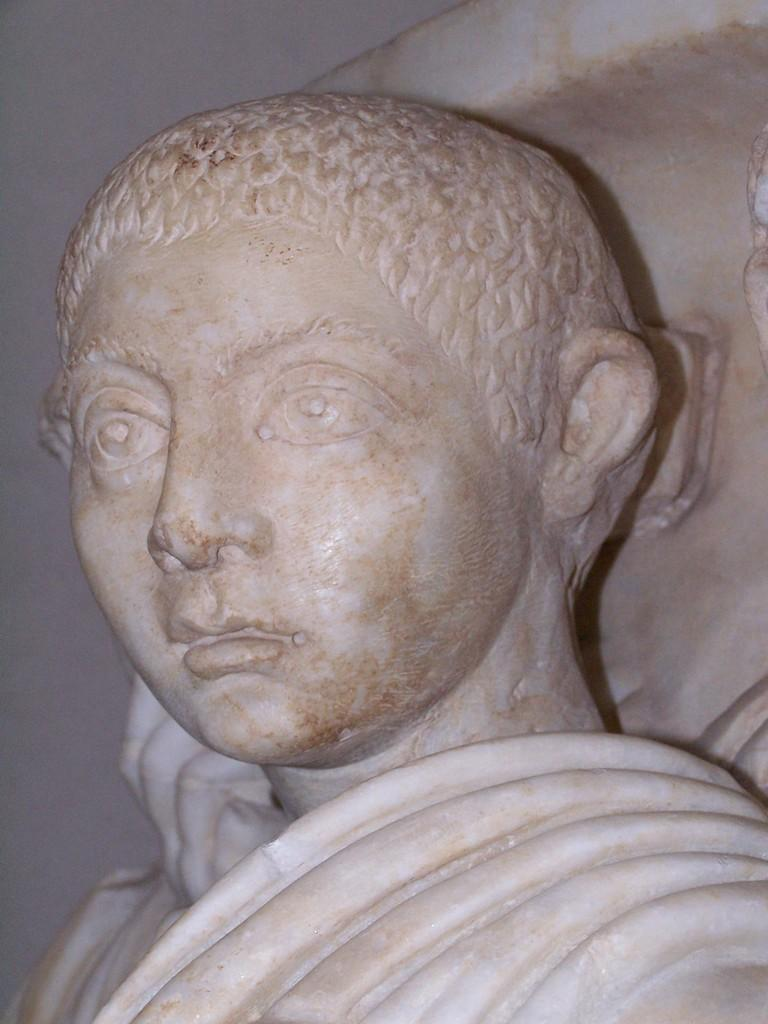What is the main subject in the image? There is a statue in the image. What type of pie is being served by the police officer in the image? There is no police officer or pie present in the image; it only features a statue. 